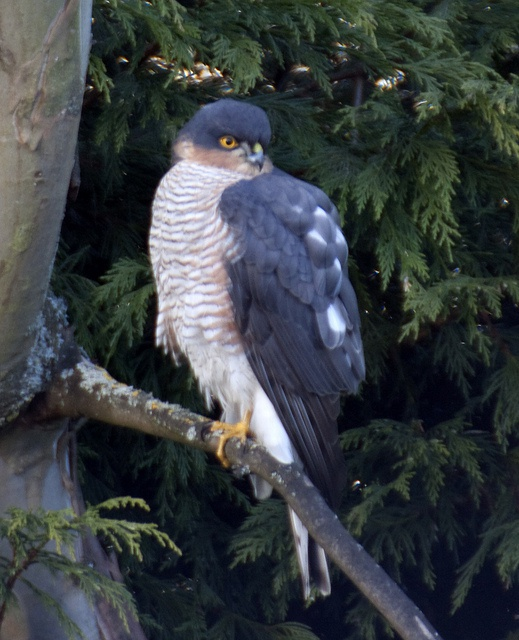Describe the objects in this image and their specific colors. I can see a bird in gray, lavender, and black tones in this image. 